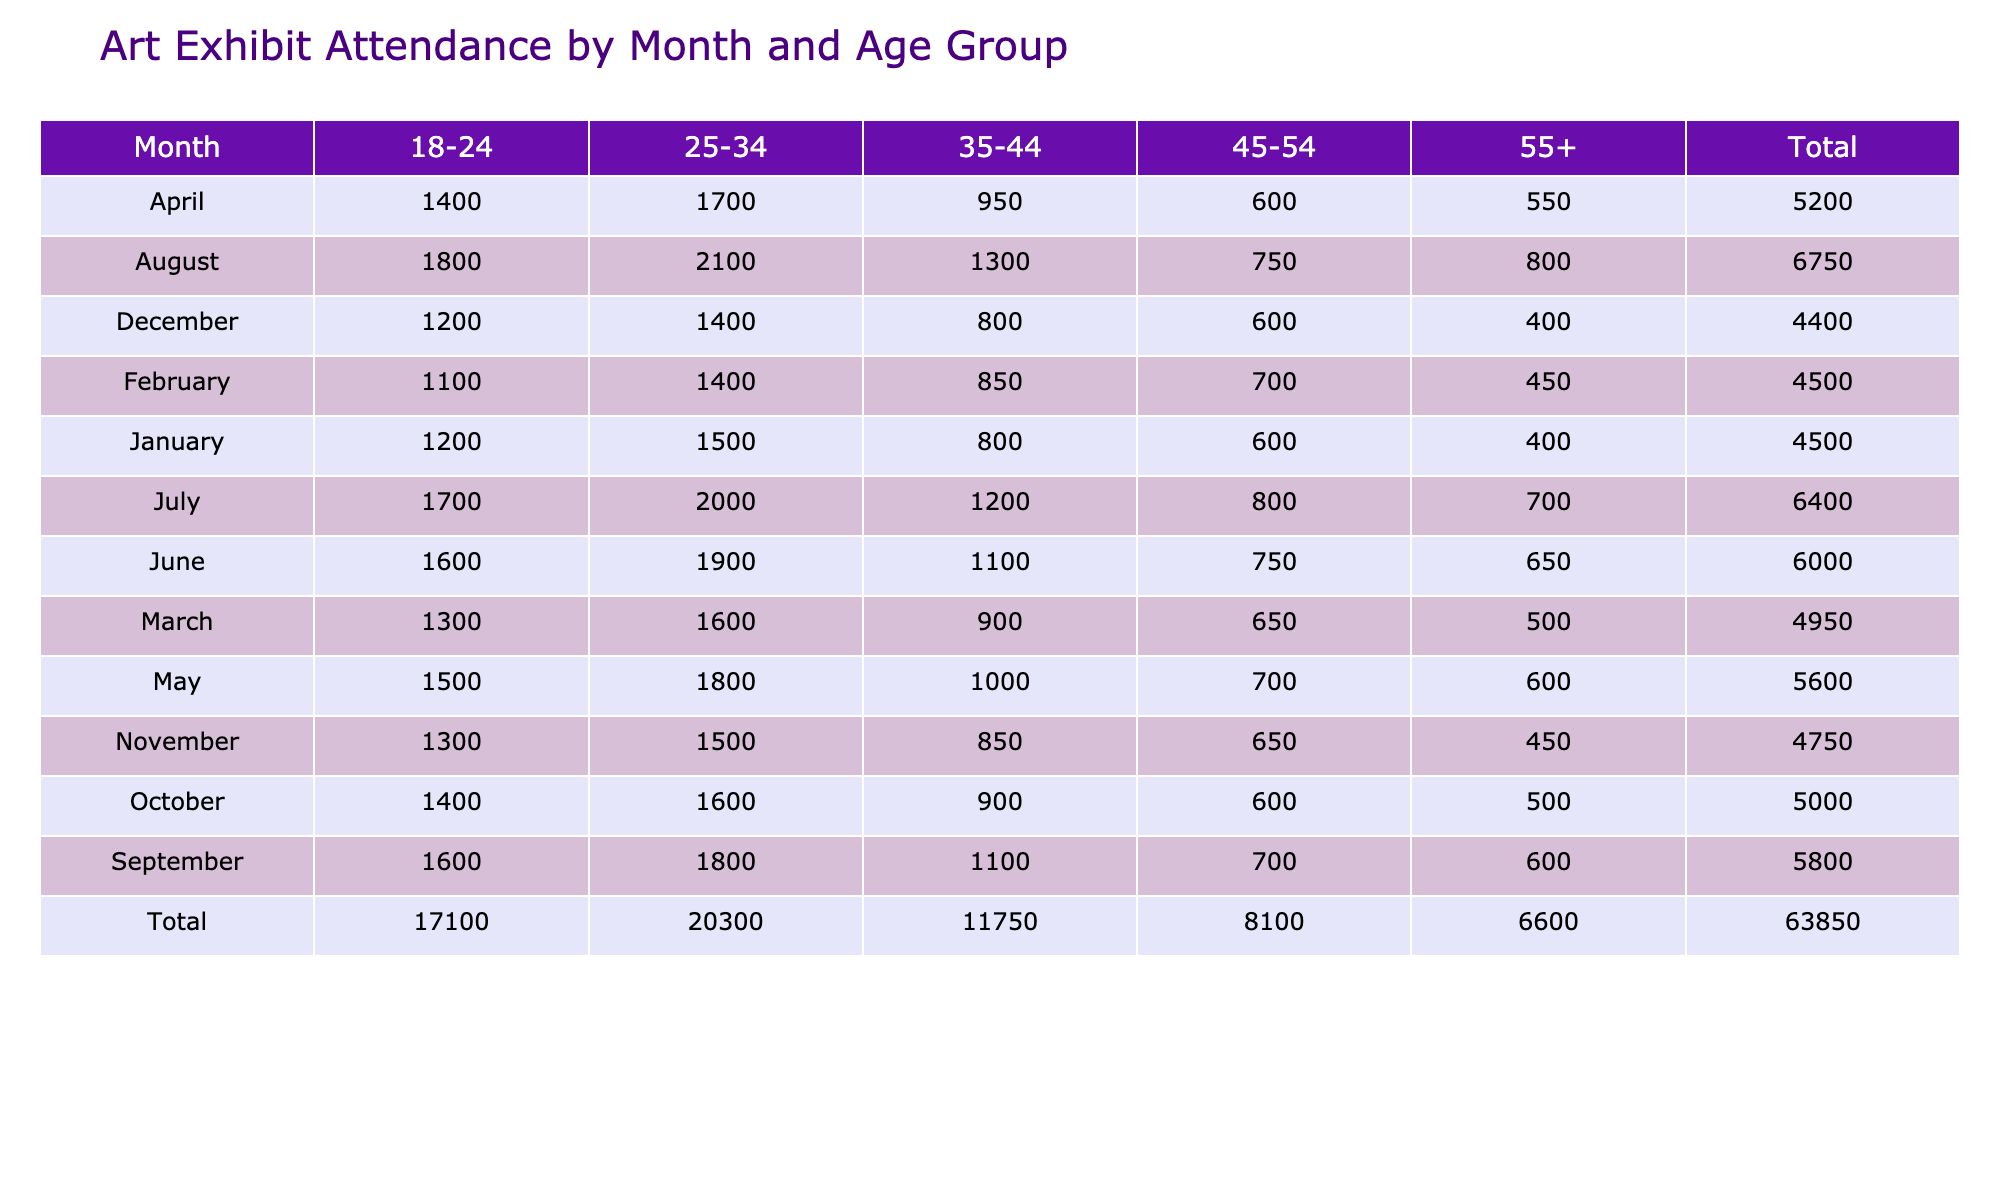What was the total attendance for the month of March? To find the total attendance for March, I need to look at the March row in the table and add the attendance figures for all age groups: 1300 (18-24) + 1600 (25-34) + 900 (35-44) + 650 (45-54) + 500 (55+) = 4950.
Answer: 4950 Which age group had the highest attendance in August? In the August row, I compare the attendance figures for each age group: 1800 (18-24), 2100 (25-34), 1300 (35-44), 750 (45-54), and 800 (55+). The highest figure is 2100 for the 25-34 age group.
Answer: 25-34 Was the total attendance for the 45-54 age group higher in June or November? I compare the total attendance for the 45-54 age group: June has 750 and November has 650. June's attendance is higher than November's.
Answer: Yes What was the average attendance for the age group 55+ across all months? First, I sum the attendance for the 55+ age group over all months: 400 + 450 + 500 + 550 + 600 + 650 + 700 + 800 + 600 + 500 + 450 + 400 = 6250. There are 12 months to consider, so the average is 6250 / 12 = 520.83, which rounds to approximately 521.
Answer: 521 In which month did the 18-24 age group see the lowest attendance? I check the attendance for the 18-24 age group across all months: January (1200), February (1100), March (1300), April (1400), May (1500), June (1600), July (1700), August (1800), September (1600), October (1400), November (1300), December (1200). The lowest attendance is in February with 1100.
Answer: February Did the total attendance for the 35-44 age group increase every month? I analyze the attendance of the 35-44 age group month by month: January (800), February (850), March (900), April (950), May (1000), June (1100), July (1200), August (1300), September (1100), October (900), November (850), December (800). I see that it didn't increase every month; it dropped in September, October, November, and December.
Answer: No Which month had the highest combined attendance across all age groups? I calculate the total attendance for each month: January (1200 + 1500 + 800 + 600 + 400 = 3500), February (1100 + 1400 + 850 + 700 + 450 = 4500), March (1300 + 1600 + 900 + 650 + 500 = 4950), April (1400 + 1700 + 950 + 600 + 550 = 5150), May (1500 + 1800 + 1000 + 700 + 600 = 4600), June (1600 + 1900 + 1100 + 750 + 650 = 6050), July (1700 + 2000 + 1200 + 800 + 700 = 6600), August (1800 + 2100 + 1300 + 750 + 800 = 6750), September (1600 + 1800 + 1100 + 700 + 600 = 4900), October (1400 + 1600 + 900 + 600 + 500 = 4100), November (1300 + 1500 + 850 + 650 + 450 = 4750), December (1200 + 1400 + 800 + 600 + 400 = 3400). The highest total attendance is in August with 6750.
Answer: August What was the attendance trend for the 25-34 age group throughout the year? Reviewing the attendance for the 25-34 age group month by month: January (1500), February (1400), March (1600), April (1700), May (1800), June (1900), July (2000), August (2100), September (1800), October (1600), November (1500), December (1400). It shows a general increase until August, followed by a decrease towards December.
Answer: Increased until August, then decreased 